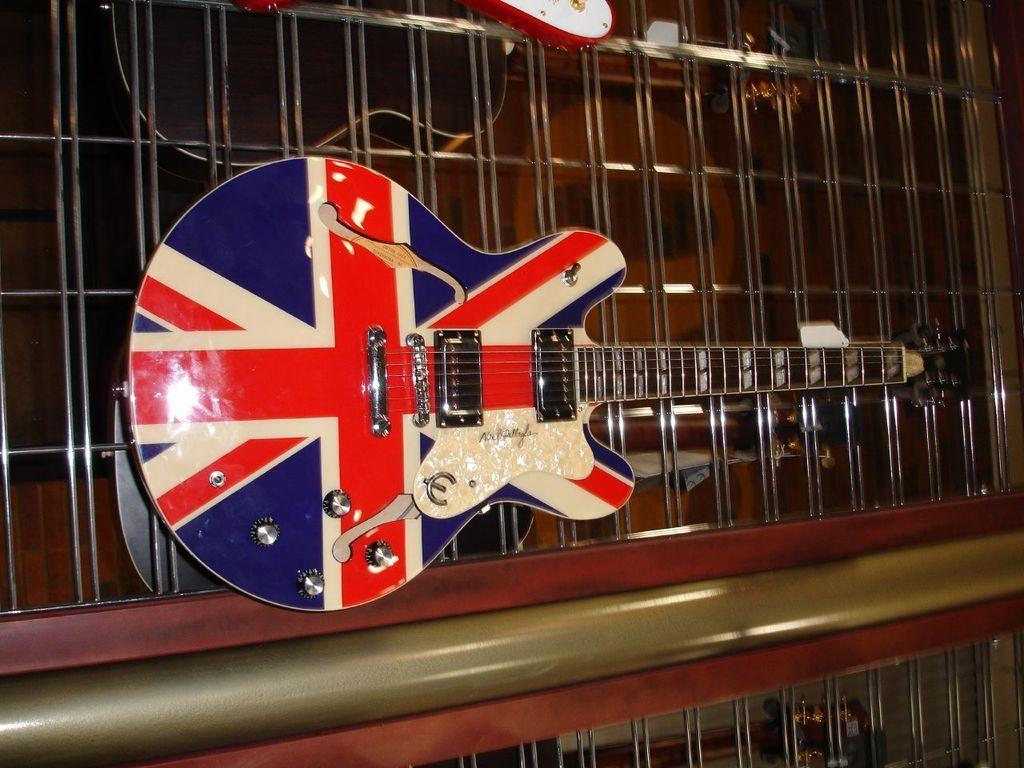Describe this image in one or two sentences. This is the picture of a musical instrument which is of three colors red, blue, white and also has some strings on it. 